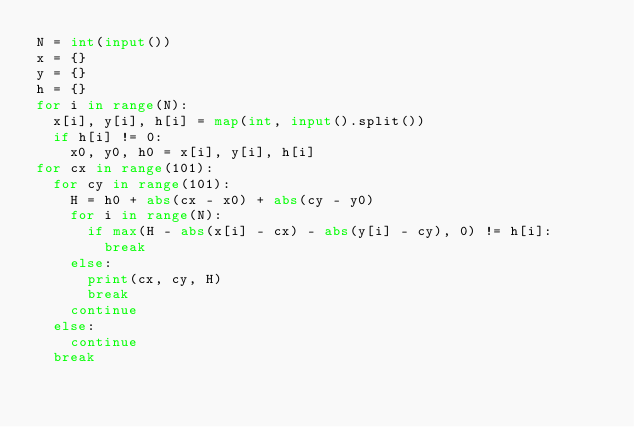Convert code to text. <code><loc_0><loc_0><loc_500><loc_500><_Python_>N = int(input())
x = {}
y = {}
h = {}
for i in range(N):
  x[i], y[i], h[i] = map(int, input().split())
  if h[i] != 0:
    x0, y0, h0 = x[i], y[i], h[i]
for cx in range(101):
  for cy in range(101):
    H = h0 + abs(cx - x0) + abs(cy - y0)
    for i in range(N):
      if max(H - abs(x[i] - cx) - abs(y[i] - cy), 0) != h[i]:
        break
    else:
      print(cx, cy, H)
      break
    continue
  else:
    continue
  break</code> 